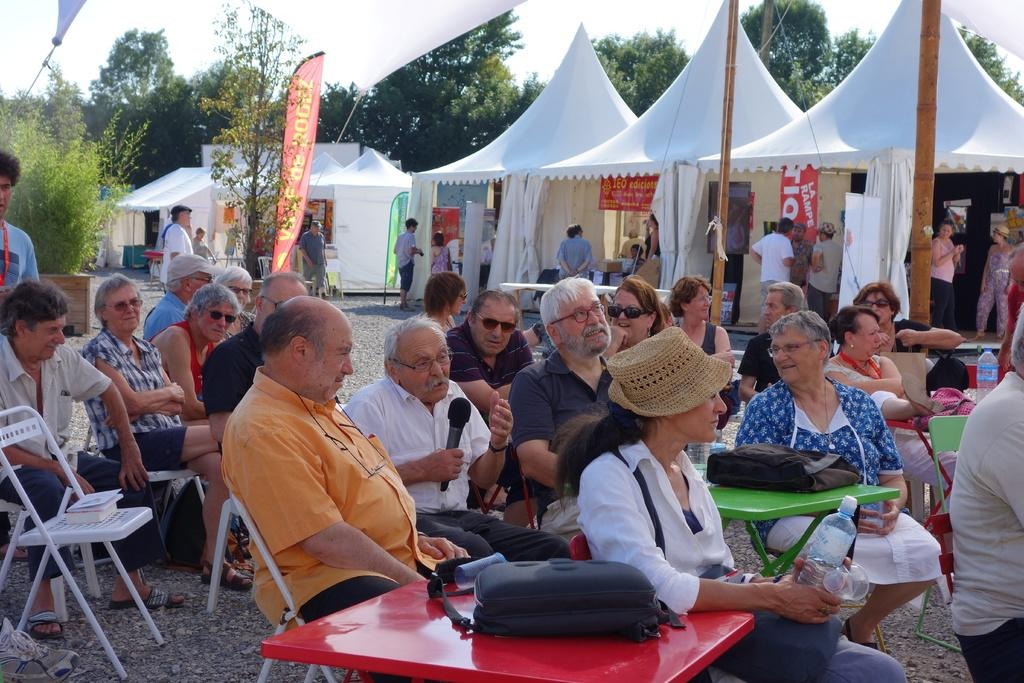What are the people in the image doing? There is a group of people sitting on chairs in the image. Who is holding a microphone among the people? There is a person holding a microphone in the image. What is the person with the microphone doing? The person holding the microphone is speaking. What can be seen in the background of the image? There is a tent and trees in the background of the image. Can you see an owl sitting on the tent in the image? There is no owl present in the image; it only features a group of people, a person holding a microphone, and a tent and trees in the background. What shape is the sponge used by the person holding the microphone? There is no sponge present in the image. 